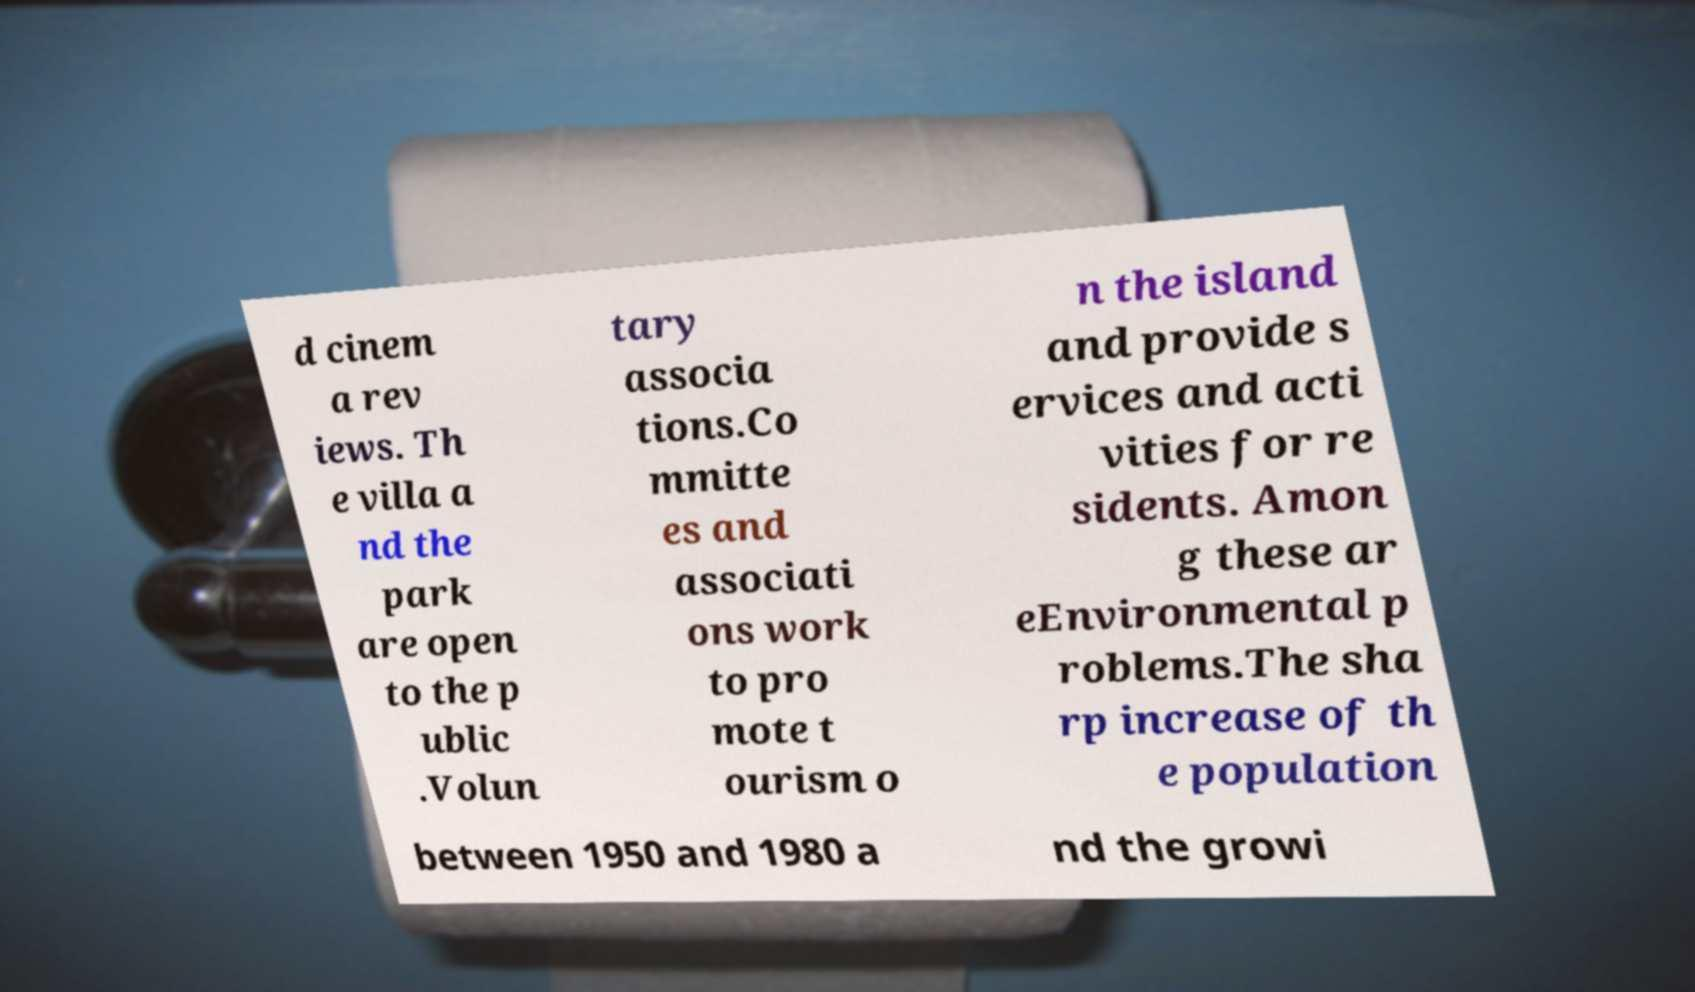Could you assist in decoding the text presented in this image and type it out clearly? d cinem a rev iews. Th e villa a nd the park are open to the p ublic .Volun tary associa tions.Co mmitte es and associati ons work to pro mote t ourism o n the island and provide s ervices and acti vities for re sidents. Amon g these ar eEnvironmental p roblems.The sha rp increase of th e population between 1950 and 1980 a nd the growi 